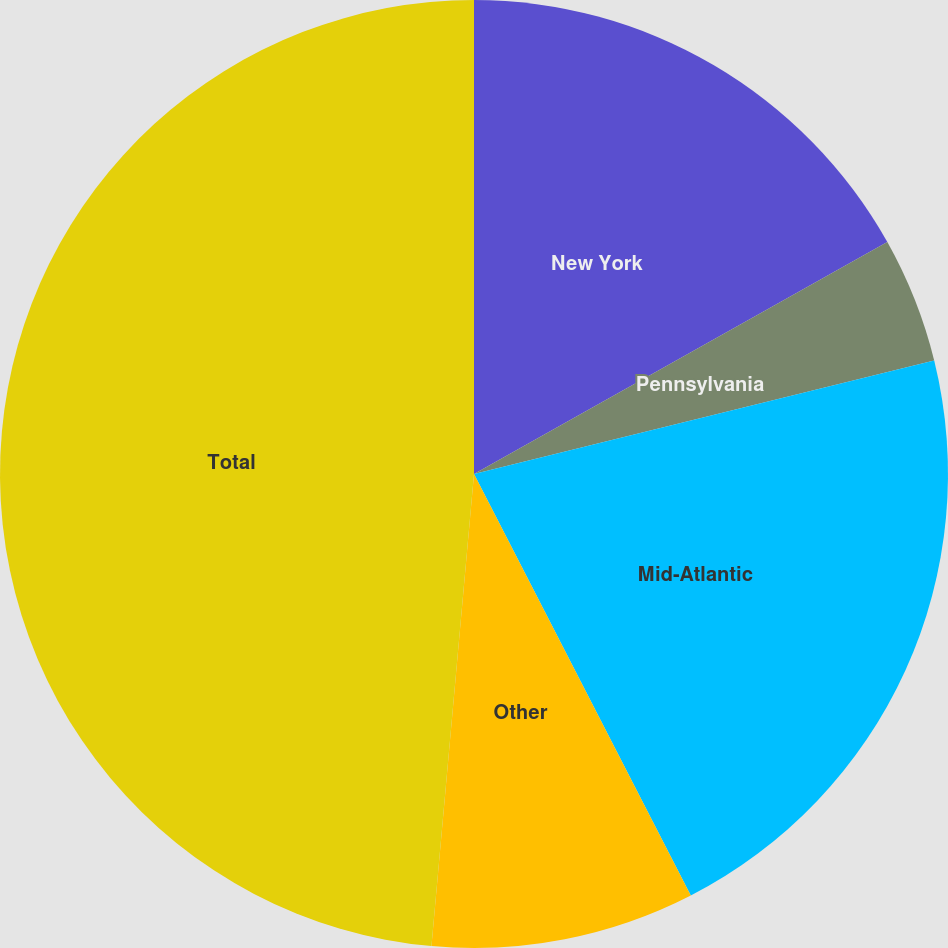<chart> <loc_0><loc_0><loc_500><loc_500><pie_chart><fcel>New York<fcel>Pennsylvania<fcel>Mid-Atlantic<fcel>Other<fcel>Total<nl><fcel>16.86%<fcel>4.29%<fcel>21.29%<fcel>8.99%<fcel>48.57%<nl></chart> 